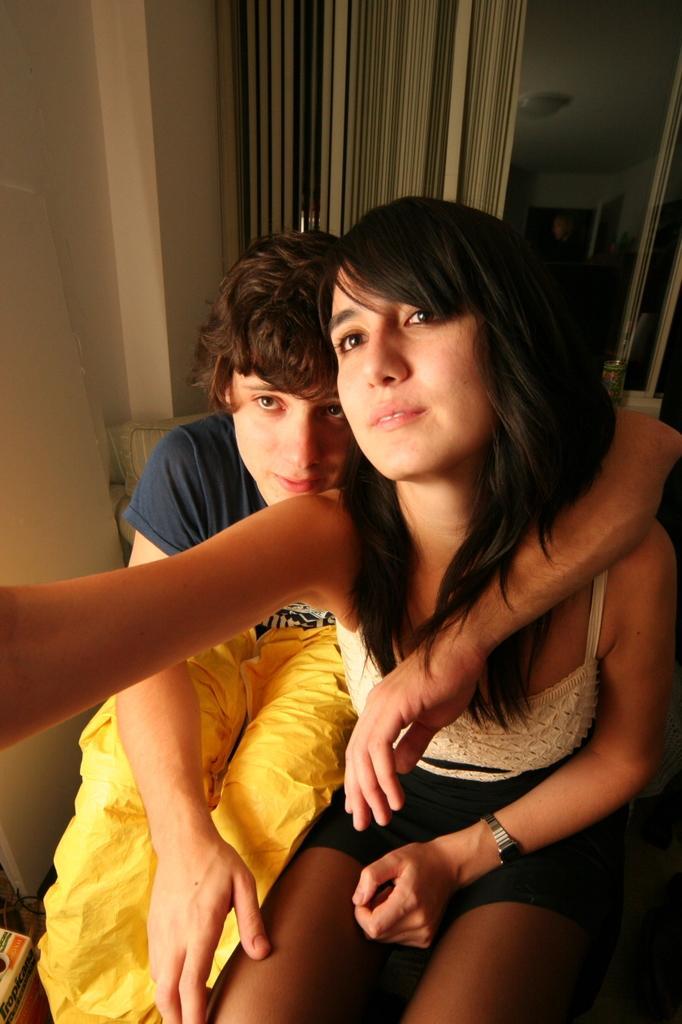Please provide a concise description of this image. In this picture I can see a girl and a boy in the middle, in the background there is a glass wall and also I can see the window curtain. 